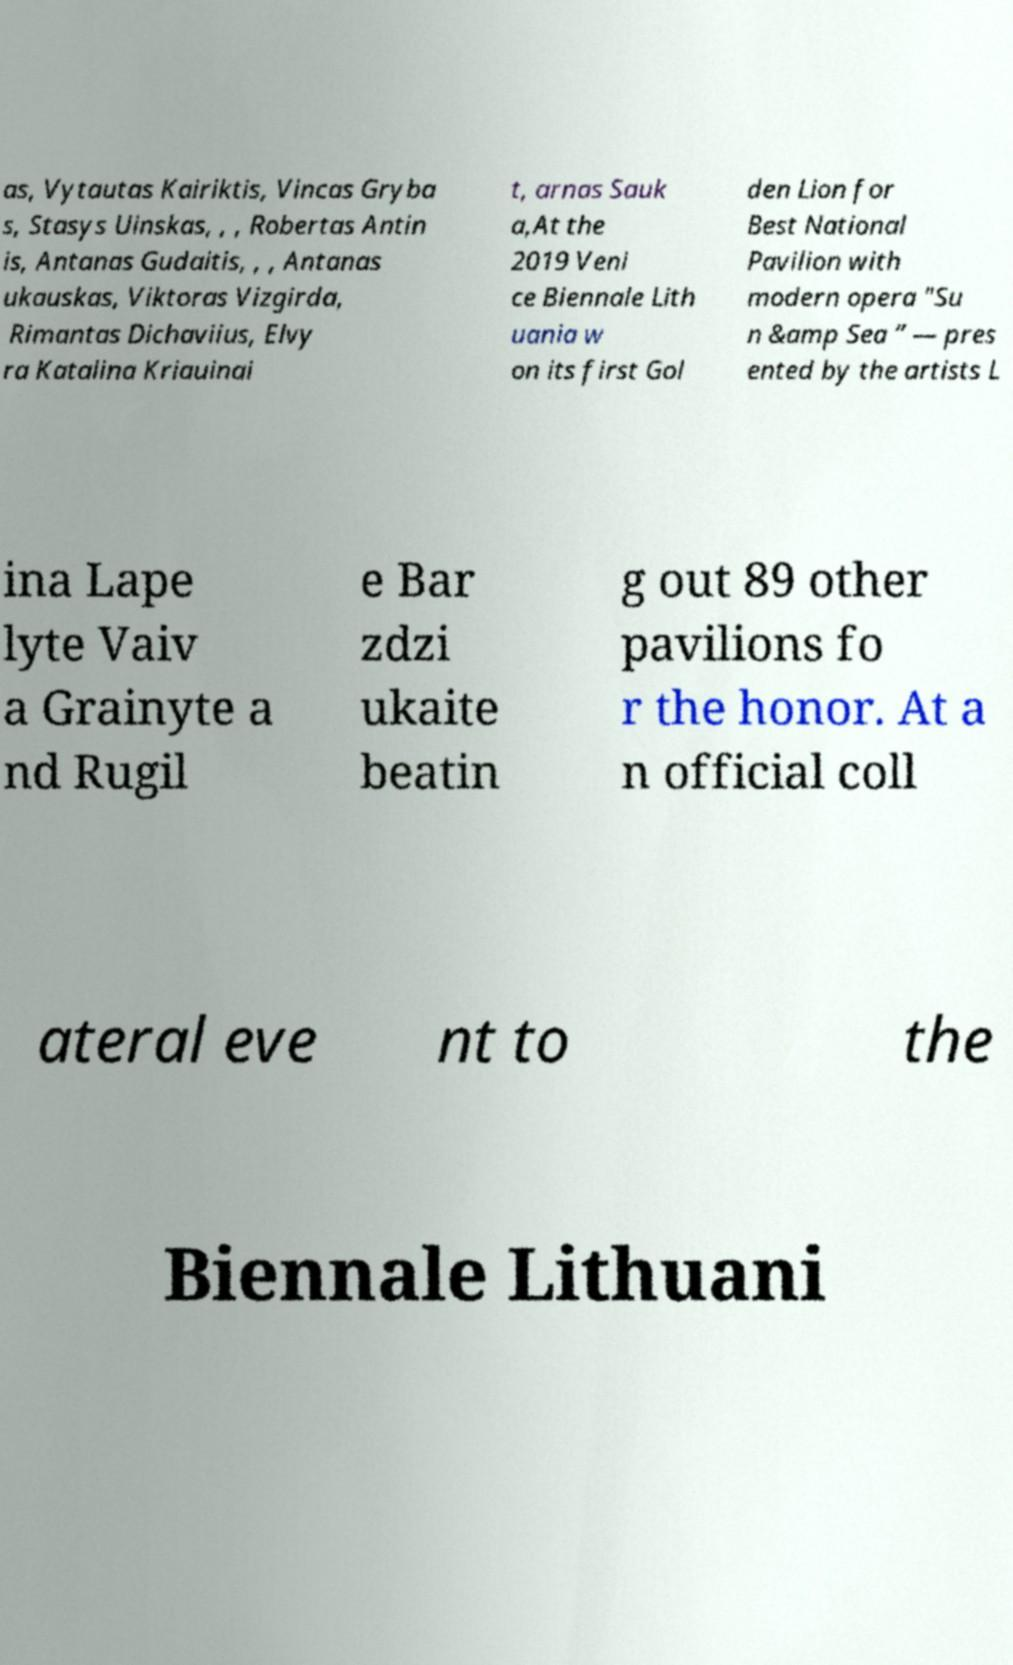Could you extract and type out the text from this image? as, Vytautas Kairiktis, Vincas Gryba s, Stasys Uinskas, , , Robertas Antin is, Antanas Gudaitis, , , Antanas ukauskas, Viktoras Vizgirda, Rimantas Dichaviius, Elvy ra Katalina Kriauinai t, arnas Sauk a,At the 2019 Veni ce Biennale Lith uania w on its first Gol den Lion for Best National Pavilion with modern opera "Su n &amp Sea ” — pres ented by the artists L ina Lape lyte Vaiv a Grainyte a nd Rugil e Bar zdzi ukaite beatin g out 89 other pavilions fo r the honor. At a n official coll ateral eve nt to the Biennale Lithuani 